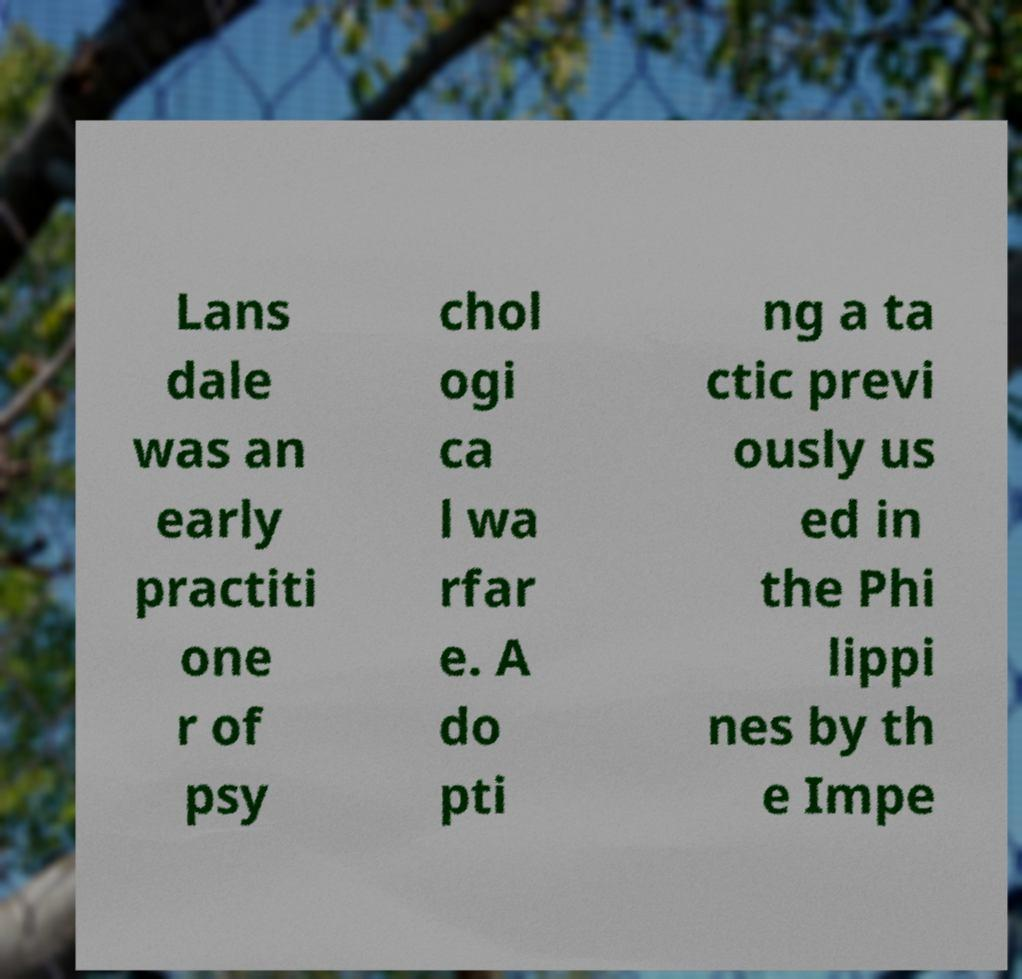There's text embedded in this image that I need extracted. Can you transcribe it verbatim? Lans dale was an early practiti one r of psy chol ogi ca l wa rfar e. A do pti ng a ta ctic previ ously us ed in the Phi lippi nes by th e Impe 